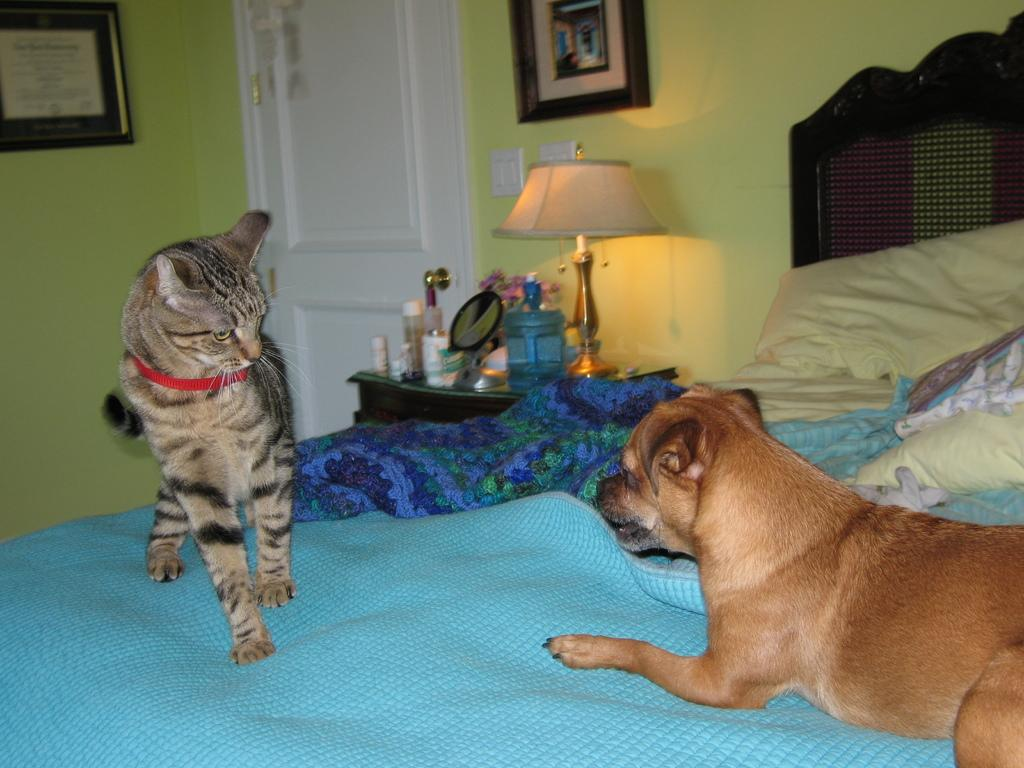What animals are present in the image? There is a dog and a cat in the image. Where are the dog and cat located? Both the dog and cat are on the bed. What other objects can be seen in the image? There is a lamp, bottles on a table, and wall paintings present in the image. What type of linen is used to cover the bed in the image? There is no information about the type of linen used to cover the bed in the image. How many balloons are floating above the dog and cat in the image? There are no balloons present in the image. 